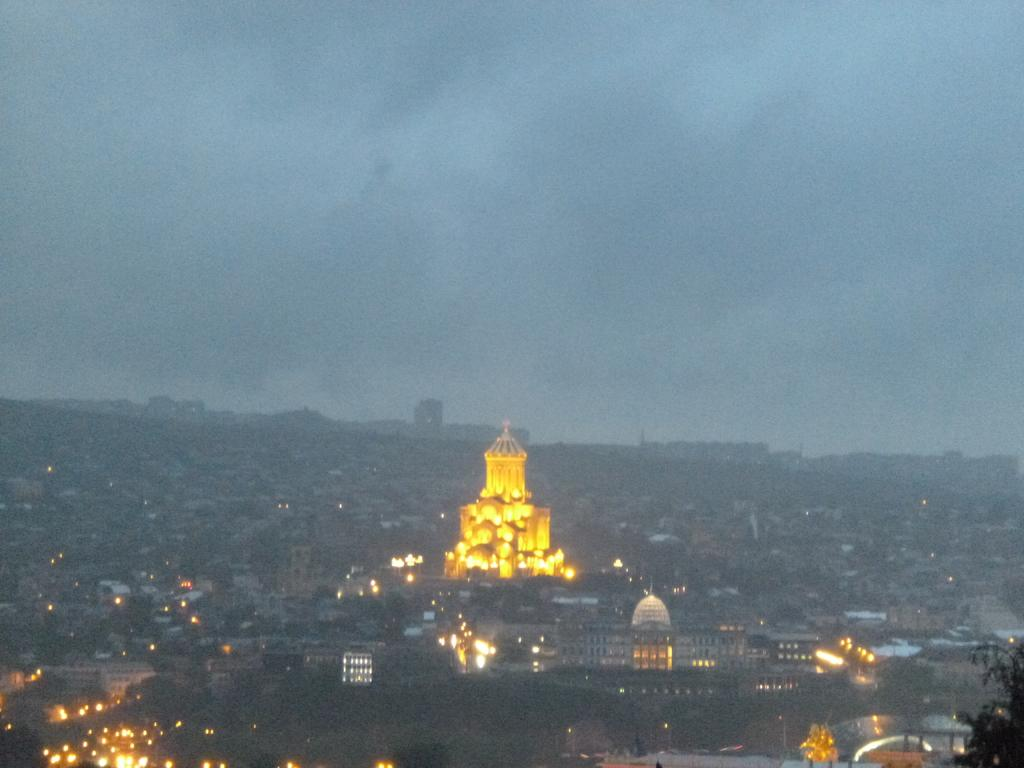What type of structures are visible at the bottom of the image? There are many buildings with lights at the bottom of the image. What is the most prominent building in the image? There is a big building with lights in the middle of the image. What can be seen in the sky in the image? The sky is visible at the top of the image, and there are clouds in the sky. What type of treatment is being administered to the list in the image? There is no list or treatment present in the image; it features buildings with lights and a sky with clouds. 